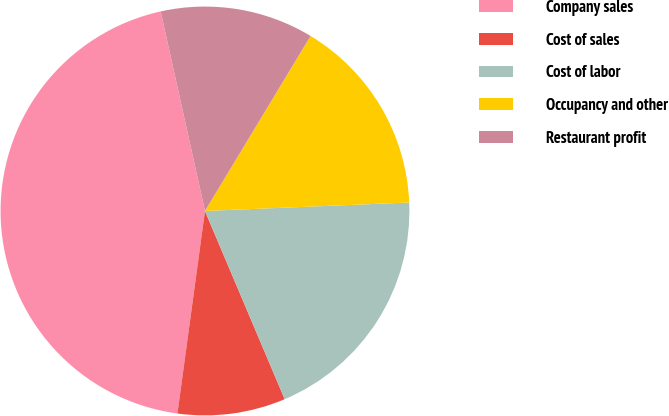<chart> <loc_0><loc_0><loc_500><loc_500><pie_chart><fcel>Company sales<fcel>Cost of sales<fcel>Cost of labor<fcel>Occupancy and other<fcel>Restaurant profit<nl><fcel>44.37%<fcel>8.53%<fcel>19.28%<fcel>15.7%<fcel>12.12%<nl></chart> 